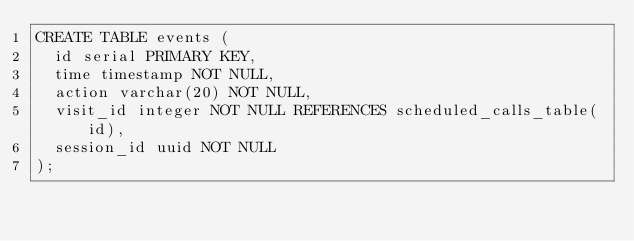<code> <loc_0><loc_0><loc_500><loc_500><_SQL_>CREATE TABLE events (
  id serial PRIMARY KEY,
  time timestamp NOT NULL,
  action varchar(20) NOT NULL,
  visit_id integer NOT NULL REFERENCES scheduled_calls_table(id),
  session_id uuid NOT NULL
);
</code> 